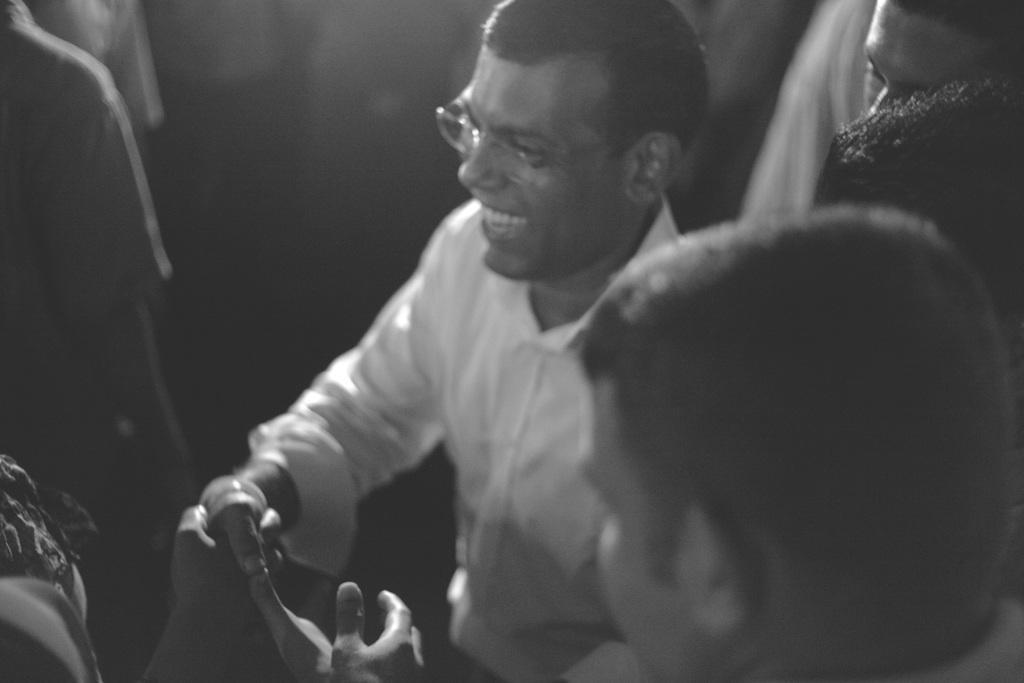Could you give a brief overview of what you see in this image? In this picture I can see few people standing and we see a man shaking hand with another human with a smile on his face and he wore spectacles. 